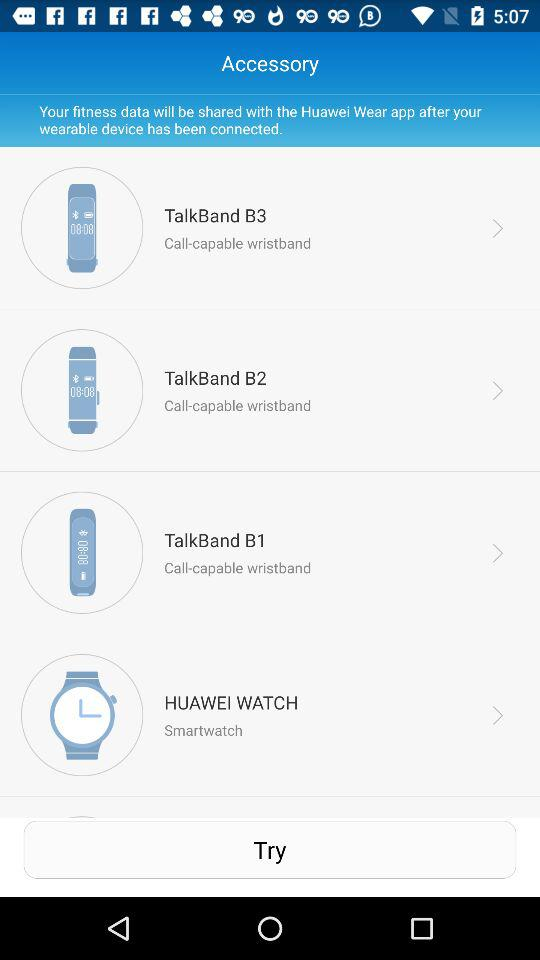How many of the wearable devices are call-capable wristbands?
Answer the question using a single word or phrase. 3 